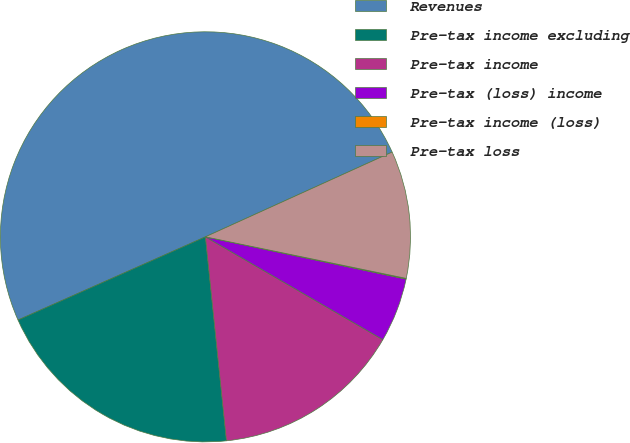Convert chart. <chart><loc_0><loc_0><loc_500><loc_500><pie_chart><fcel>Revenues<fcel>Pre-tax income excluding<fcel>Pre-tax income<fcel>Pre-tax (loss) income<fcel>Pre-tax income (loss)<fcel>Pre-tax loss<nl><fcel>49.87%<fcel>19.99%<fcel>15.01%<fcel>5.05%<fcel>0.06%<fcel>10.03%<nl></chart> 